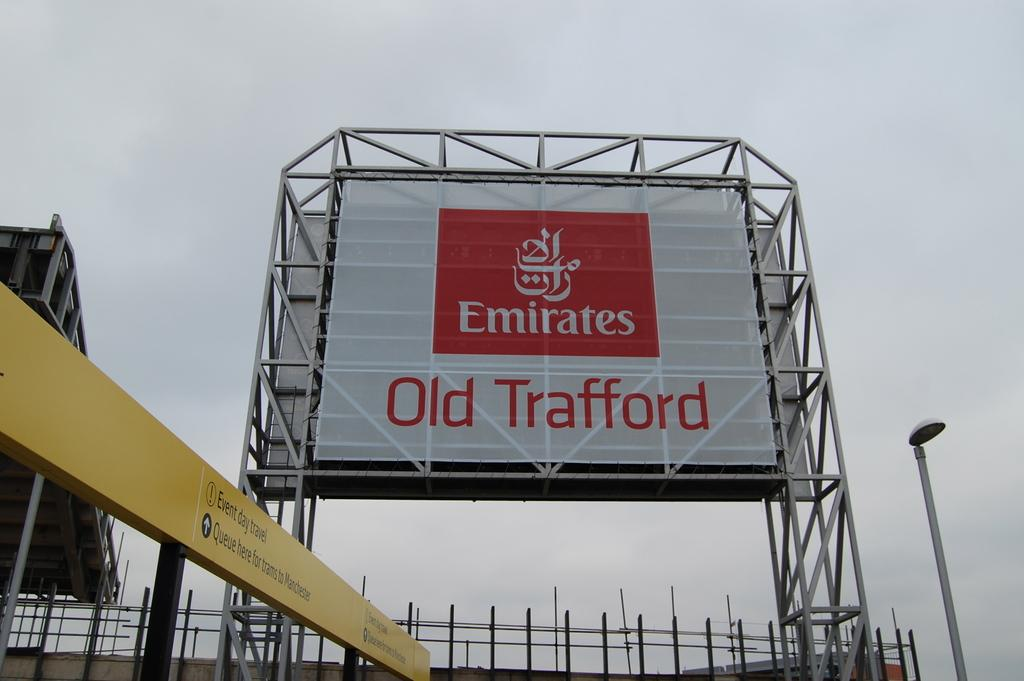<image>
Offer a succinct explanation of the picture presented. An advertisement for Emirates Old Trafford dominates the view. 